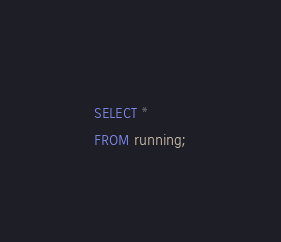Convert code to text. <code><loc_0><loc_0><loc_500><loc_500><_SQL_>SELECT *
FROM running;</code> 